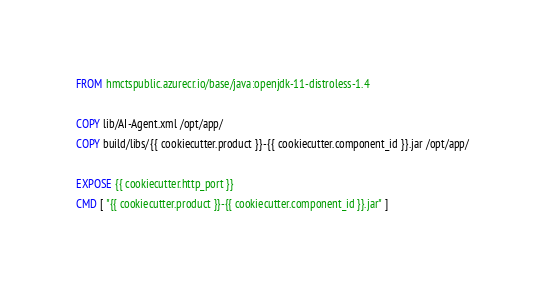Convert code to text. <code><loc_0><loc_0><loc_500><loc_500><_Dockerfile_>FROM hmctspublic.azurecr.io/base/java:openjdk-11-distroless-1.4

COPY lib/AI-Agent.xml /opt/app/
COPY build/libs/{{ cookiecutter.product }}-{{ cookiecutter.component_id }}.jar /opt/app/

EXPOSE {{ cookiecutter.http_port }}
CMD [ "{{ cookiecutter.product }}-{{ cookiecutter.component_id }}.jar" ]
</code> 